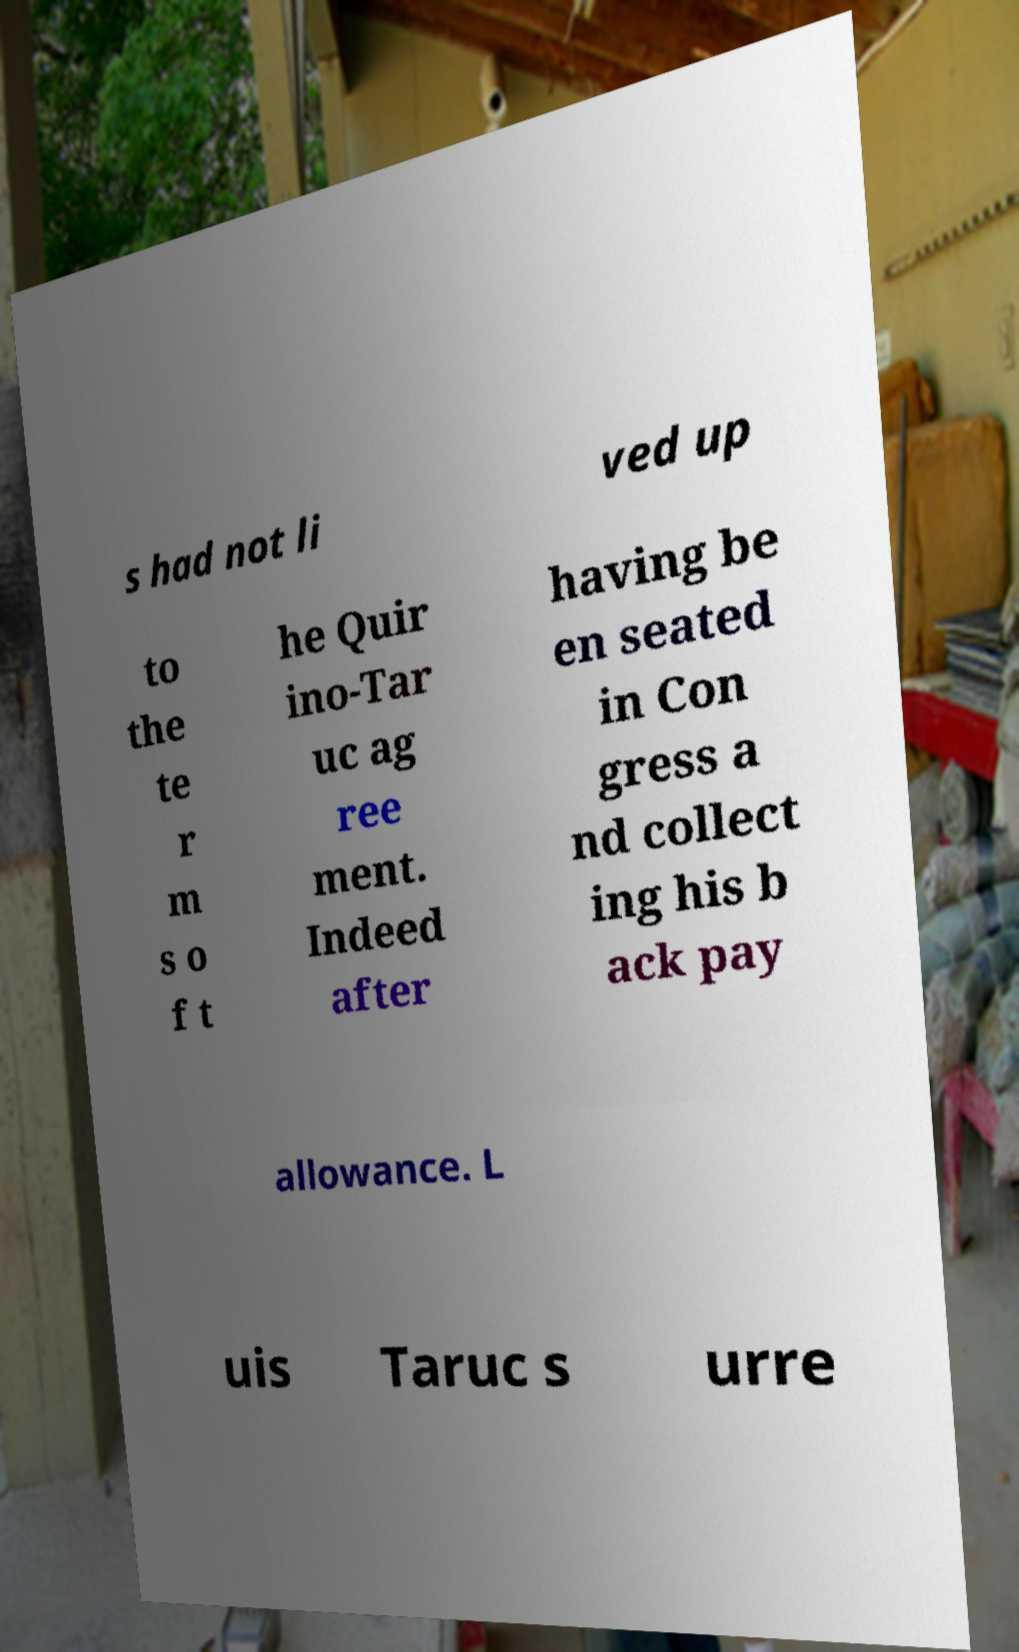I need the written content from this picture converted into text. Can you do that? s had not li ved up to the te r m s o f t he Quir ino-Tar uc ag ree ment. Indeed after having be en seated in Con gress a nd collect ing his b ack pay allowance. L uis Taruc s urre 